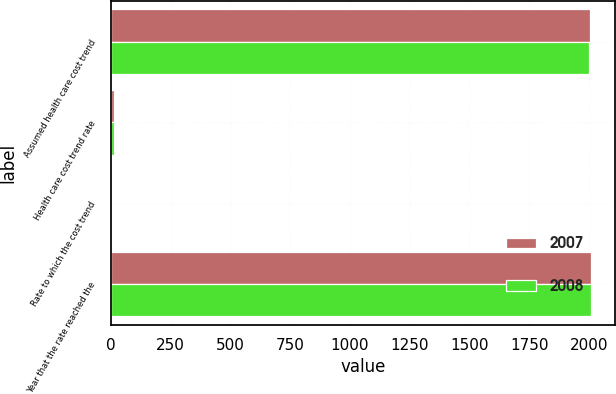<chart> <loc_0><loc_0><loc_500><loc_500><stacked_bar_chart><ecel><fcel>Assumed health care cost trend<fcel>Health care cost trend rate<fcel>Rate to which the cost trend<fcel>Year that the rate reached the<nl><fcel>2007<fcel>2004<fcel>11.5<fcel>5<fcel>2008<nl><fcel>2008<fcel>2002<fcel>13<fcel>5<fcel>2007<nl></chart> 